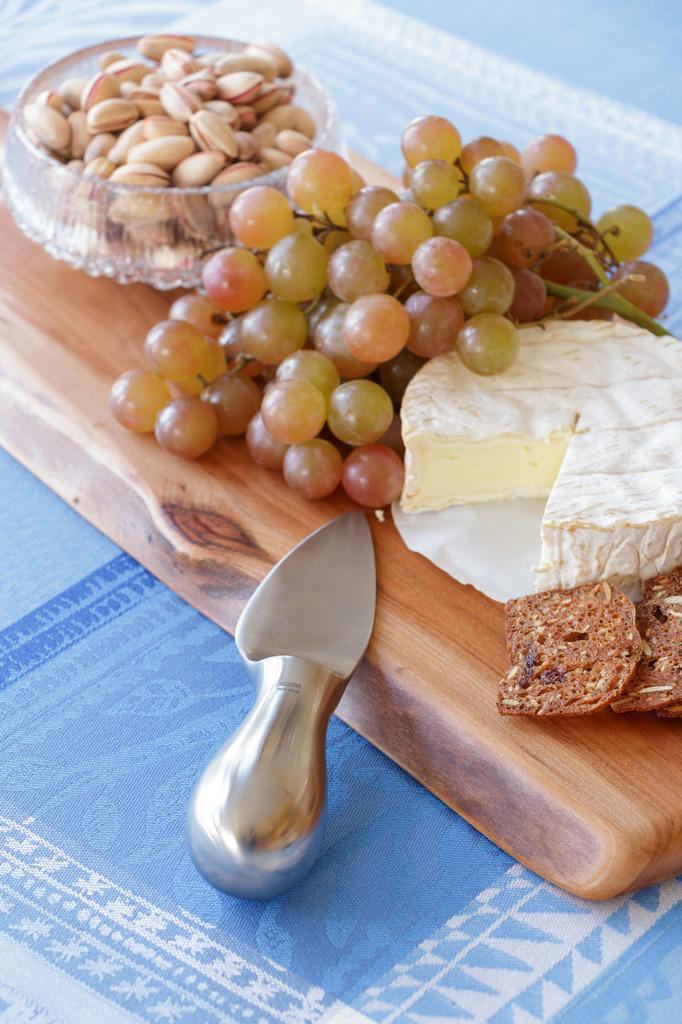Please provide a concise description of this image. In the picture we can see the grapes, almonds in the bowl, a slice of the butter, and a knife on the wooden plank. 